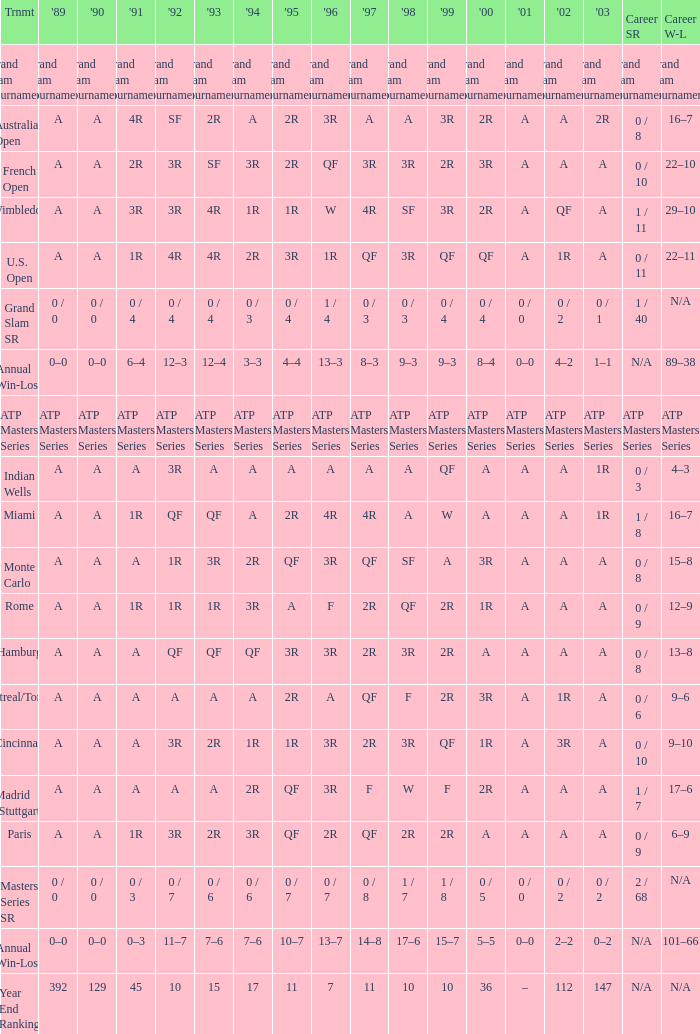What was the value in 1989 with QF in 1997 and A in 1993? A. 